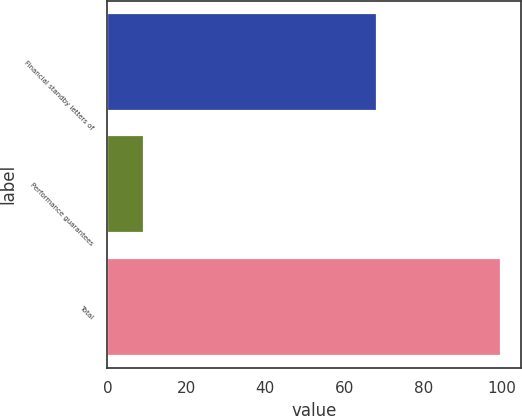Convert chart to OTSL. <chart><loc_0><loc_0><loc_500><loc_500><bar_chart><fcel>Financial standby letters of<fcel>Performance guarantees<fcel>Total<nl><fcel>68.3<fcel>9.2<fcel>99.7<nl></chart> 